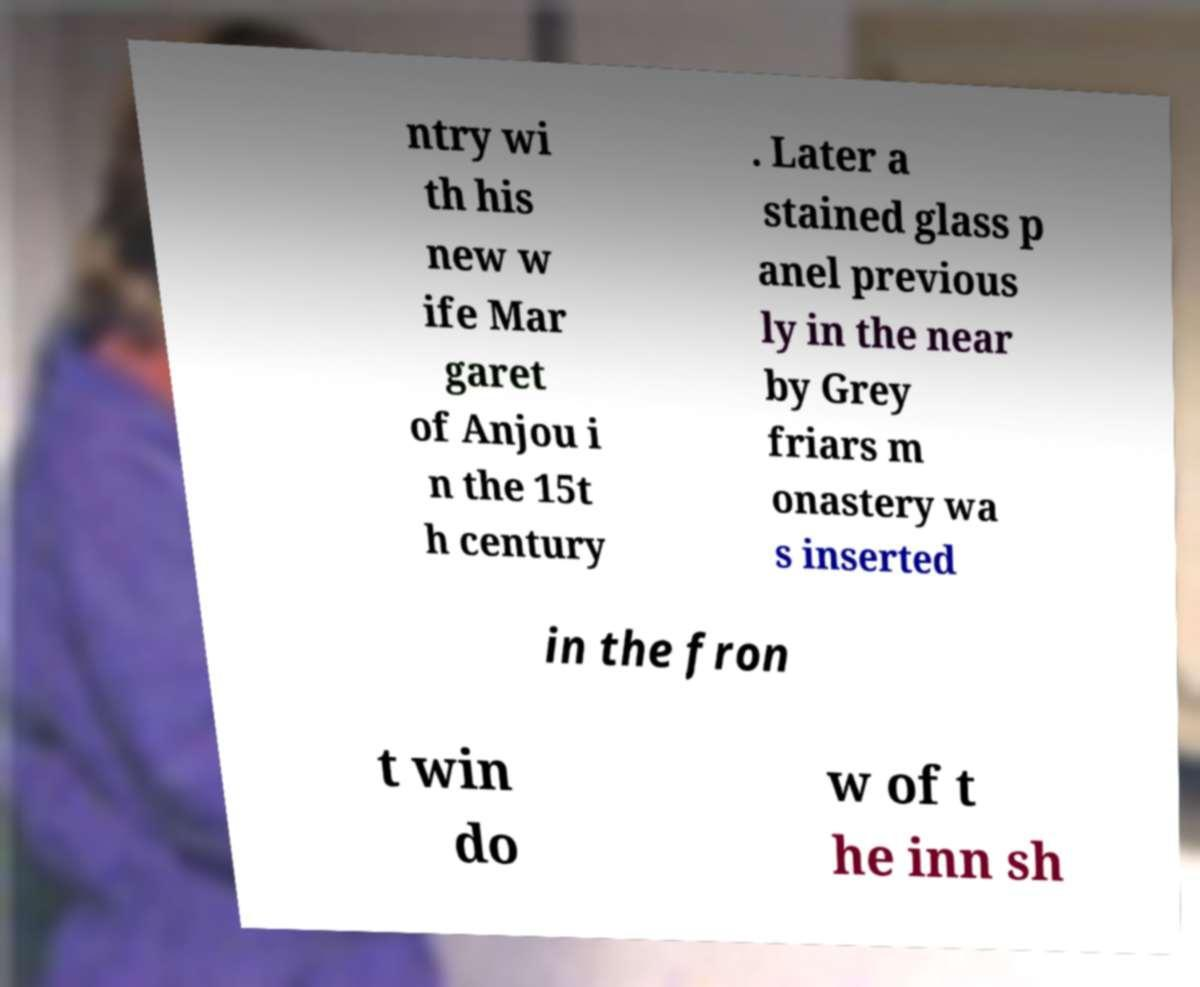What messages or text are displayed in this image? I need them in a readable, typed format. ntry wi th his new w ife Mar garet of Anjou i n the 15t h century . Later a stained glass p anel previous ly in the near by Grey friars m onastery wa s inserted in the fron t win do w of t he inn sh 